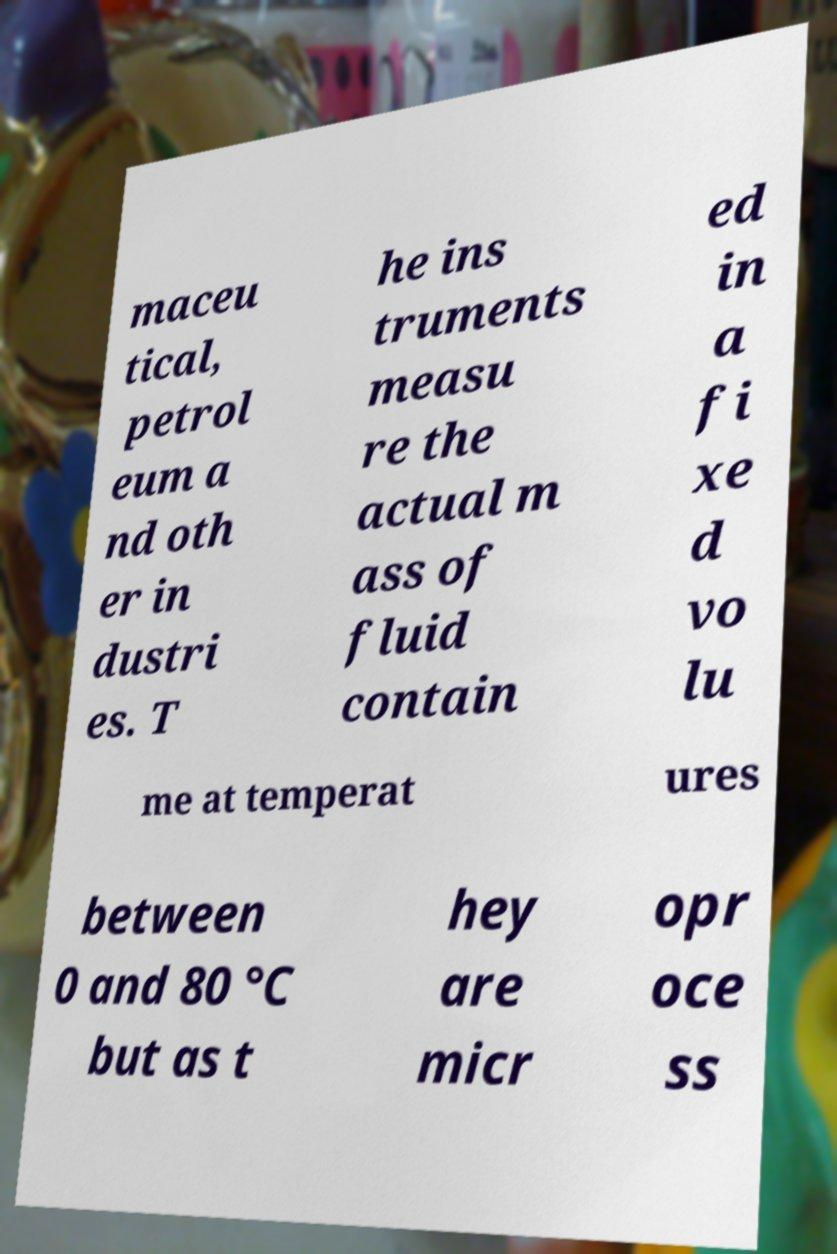For documentation purposes, I need the text within this image transcribed. Could you provide that? maceu tical, petrol eum a nd oth er in dustri es. T he ins truments measu re the actual m ass of fluid contain ed in a fi xe d vo lu me at temperat ures between 0 and 80 °C but as t hey are micr opr oce ss 